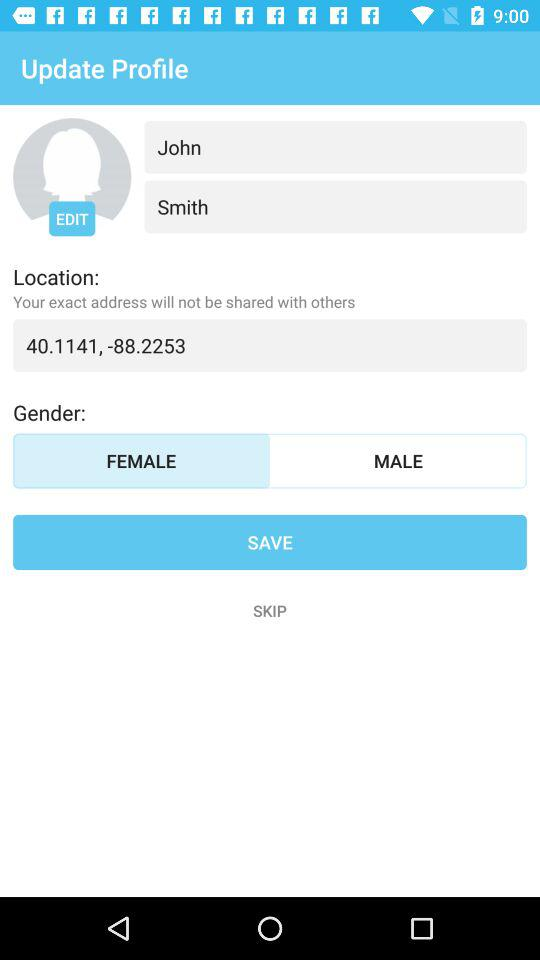What is the user name? The user name is John Smith. 